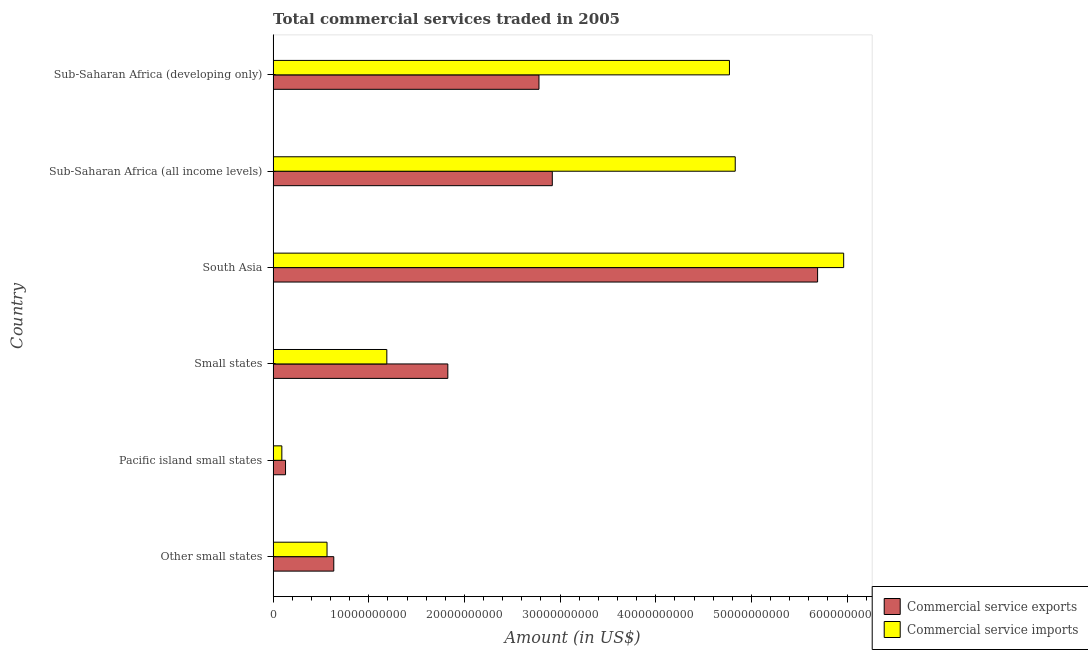Are the number of bars per tick equal to the number of legend labels?
Give a very brief answer. Yes. Are the number of bars on each tick of the Y-axis equal?
Offer a very short reply. Yes. How many bars are there on the 2nd tick from the bottom?
Offer a terse response. 2. What is the label of the 5th group of bars from the top?
Offer a very short reply. Pacific island small states. In how many cases, is the number of bars for a given country not equal to the number of legend labels?
Your answer should be compact. 0. What is the amount of commercial service exports in South Asia?
Offer a very short reply. 5.69e+1. Across all countries, what is the maximum amount of commercial service imports?
Give a very brief answer. 5.96e+1. Across all countries, what is the minimum amount of commercial service imports?
Provide a succinct answer. 9.12e+08. In which country was the amount of commercial service exports maximum?
Offer a very short reply. South Asia. In which country was the amount of commercial service imports minimum?
Your answer should be very brief. Pacific island small states. What is the total amount of commercial service imports in the graph?
Your answer should be compact. 1.74e+11. What is the difference between the amount of commercial service imports in Small states and that in South Asia?
Provide a short and direct response. -4.78e+1. What is the difference between the amount of commercial service exports in Small states and the amount of commercial service imports in Other small states?
Provide a succinct answer. 1.26e+1. What is the average amount of commercial service exports per country?
Your response must be concise. 2.33e+1. What is the difference between the amount of commercial service exports and amount of commercial service imports in Small states?
Make the answer very short. 6.38e+09. What is the ratio of the amount of commercial service exports in Pacific island small states to that in South Asia?
Provide a succinct answer. 0.02. Is the difference between the amount of commercial service imports in Pacific island small states and South Asia greater than the difference between the amount of commercial service exports in Pacific island small states and South Asia?
Your response must be concise. No. What is the difference between the highest and the second highest amount of commercial service imports?
Offer a terse response. 1.13e+1. What is the difference between the highest and the lowest amount of commercial service exports?
Make the answer very short. 5.56e+1. What does the 1st bar from the top in Other small states represents?
Provide a short and direct response. Commercial service imports. What does the 2nd bar from the bottom in Pacific island small states represents?
Offer a terse response. Commercial service imports. Are the values on the major ticks of X-axis written in scientific E-notation?
Offer a terse response. No. Does the graph contain any zero values?
Your answer should be compact. No. Does the graph contain grids?
Offer a very short reply. No. How are the legend labels stacked?
Offer a terse response. Vertical. What is the title of the graph?
Offer a very short reply. Total commercial services traded in 2005. Does "Highest 10% of population" appear as one of the legend labels in the graph?
Your answer should be very brief. No. What is the Amount (in US$) in Commercial service exports in Other small states?
Provide a short and direct response. 6.34e+09. What is the Amount (in US$) in Commercial service imports in Other small states?
Offer a terse response. 5.63e+09. What is the Amount (in US$) in Commercial service exports in Pacific island small states?
Offer a terse response. 1.30e+09. What is the Amount (in US$) in Commercial service imports in Pacific island small states?
Your answer should be compact. 9.12e+08. What is the Amount (in US$) of Commercial service exports in Small states?
Provide a short and direct response. 1.83e+1. What is the Amount (in US$) of Commercial service imports in Small states?
Offer a very short reply. 1.19e+1. What is the Amount (in US$) of Commercial service exports in South Asia?
Ensure brevity in your answer.  5.69e+1. What is the Amount (in US$) in Commercial service imports in South Asia?
Your answer should be very brief. 5.96e+1. What is the Amount (in US$) in Commercial service exports in Sub-Saharan Africa (all income levels)?
Ensure brevity in your answer.  2.92e+1. What is the Amount (in US$) in Commercial service imports in Sub-Saharan Africa (all income levels)?
Make the answer very short. 4.83e+1. What is the Amount (in US$) in Commercial service exports in Sub-Saharan Africa (developing only)?
Your answer should be very brief. 2.78e+1. What is the Amount (in US$) in Commercial service imports in Sub-Saharan Africa (developing only)?
Ensure brevity in your answer.  4.77e+1. Across all countries, what is the maximum Amount (in US$) in Commercial service exports?
Offer a very short reply. 5.69e+1. Across all countries, what is the maximum Amount (in US$) of Commercial service imports?
Provide a succinct answer. 5.96e+1. Across all countries, what is the minimum Amount (in US$) in Commercial service exports?
Your answer should be very brief. 1.30e+09. Across all countries, what is the minimum Amount (in US$) in Commercial service imports?
Keep it short and to the point. 9.12e+08. What is the total Amount (in US$) of Commercial service exports in the graph?
Keep it short and to the point. 1.40e+11. What is the total Amount (in US$) of Commercial service imports in the graph?
Your answer should be very brief. 1.74e+11. What is the difference between the Amount (in US$) in Commercial service exports in Other small states and that in Pacific island small states?
Give a very brief answer. 5.04e+09. What is the difference between the Amount (in US$) in Commercial service imports in Other small states and that in Pacific island small states?
Keep it short and to the point. 4.72e+09. What is the difference between the Amount (in US$) of Commercial service exports in Other small states and that in Small states?
Give a very brief answer. -1.19e+1. What is the difference between the Amount (in US$) in Commercial service imports in Other small states and that in Small states?
Your answer should be compact. -6.25e+09. What is the difference between the Amount (in US$) in Commercial service exports in Other small states and that in South Asia?
Offer a very short reply. -5.06e+1. What is the difference between the Amount (in US$) in Commercial service imports in Other small states and that in South Asia?
Make the answer very short. -5.40e+1. What is the difference between the Amount (in US$) of Commercial service exports in Other small states and that in Sub-Saharan Africa (all income levels)?
Your answer should be very brief. -2.28e+1. What is the difference between the Amount (in US$) of Commercial service imports in Other small states and that in Sub-Saharan Africa (all income levels)?
Make the answer very short. -4.27e+1. What is the difference between the Amount (in US$) of Commercial service exports in Other small states and that in Sub-Saharan Africa (developing only)?
Offer a terse response. -2.14e+1. What is the difference between the Amount (in US$) in Commercial service imports in Other small states and that in Sub-Saharan Africa (developing only)?
Keep it short and to the point. -4.21e+1. What is the difference between the Amount (in US$) in Commercial service exports in Pacific island small states and that in Small states?
Your answer should be compact. -1.70e+1. What is the difference between the Amount (in US$) of Commercial service imports in Pacific island small states and that in Small states?
Offer a terse response. -1.10e+1. What is the difference between the Amount (in US$) of Commercial service exports in Pacific island small states and that in South Asia?
Give a very brief answer. -5.56e+1. What is the difference between the Amount (in US$) of Commercial service imports in Pacific island small states and that in South Asia?
Your answer should be compact. -5.87e+1. What is the difference between the Amount (in US$) in Commercial service exports in Pacific island small states and that in Sub-Saharan Africa (all income levels)?
Keep it short and to the point. -2.79e+1. What is the difference between the Amount (in US$) of Commercial service imports in Pacific island small states and that in Sub-Saharan Africa (all income levels)?
Ensure brevity in your answer.  -4.74e+1. What is the difference between the Amount (in US$) of Commercial service exports in Pacific island small states and that in Sub-Saharan Africa (developing only)?
Provide a short and direct response. -2.65e+1. What is the difference between the Amount (in US$) in Commercial service imports in Pacific island small states and that in Sub-Saharan Africa (developing only)?
Keep it short and to the point. -4.68e+1. What is the difference between the Amount (in US$) in Commercial service exports in Small states and that in South Asia?
Your response must be concise. -3.87e+1. What is the difference between the Amount (in US$) in Commercial service imports in Small states and that in South Asia?
Keep it short and to the point. -4.78e+1. What is the difference between the Amount (in US$) of Commercial service exports in Small states and that in Sub-Saharan Africa (all income levels)?
Provide a succinct answer. -1.09e+1. What is the difference between the Amount (in US$) of Commercial service imports in Small states and that in Sub-Saharan Africa (all income levels)?
Keep it short and to the point. -3.64e+1. What is the difference between the Amount (in US$) in Commercial service exports in Small states and that in Sub-Saharan Africa (developing only)?
Your answer should be compact. -9.53e+09. What is the difference between the Amount (in US$) in Commercial service imports in Small states and that in Sub-Saharan Africa (developing only)?
Your response must be concise. -3.58e+1. What is the difference between the Amount (in US$) in Commercial service exports in South Asia and that in Sub-Saharan Africa (all income levels)?
Your response must be concise. 2.77e+1. What is the difference between the Amount (in US$) in Commercial service imports in South Asia and that in Sub-Saharan Africa (all income levels)?
Offer a very short reply. 1.13e+1. What is the difference between the Amount (in US$) in Commercial service exports in South Asia and that in Sub-Saharan Africa (developing only)?
Ensure brevity in your answer.  2.91e+1. What is the difference between the Amount (in US$) of Commercial service imports in South Asia and that in Sub-Saharan Africa (developing only)?
Provide a short and direct response. 1.19e+1. What is the difference between the Amount (in US$) in Commercial service exports in Sub-Saharan Africa (all income levels) and that in Sub-Saharan Africa (developing only)?
Offer a very short reply. 1.39e+09. What is the difference between the Amount (in US$) in Commercial service imports in Sub-Saharan Africa (all income levels) and that in Sub-Saharan Africa (developing only)?
Your answer should be very brief. 6.03e+08. What is the difference between the Amount (in US$) in Commercial service exports in Other small states and the Amount (in US$) in Commercial service imports in Pacific island small states?
Offer a very short reply. 5.43e+09. What is the difference between the Amount (in US$) in Commercial service exports in Other small states and the Amount (in US$) in Commercial service imports in Small states?
Ensure brevity in your answer.  -5.54e+09. What is the difference between the Amount (in US$) of Commercial service exports in Other small states and the Amount (in US$) of Commercial service imports in South Asia?
Offer a terse response. -5.33e+1. What is the difference between the Amount (in US$) of Commercial service exports in Other small states and the Amount (in US$) of Commercial service imports in Sub-Saharan Africa (all income levels)?
Your response must be concise. -4.20e+1. What is the difference between the Amount (in US$) of Commercial service exports in Other small states and the Amount (in US$) of Commercial service imports in Sub-Saharan Africa (developing only)?
Give a very brief answer. -4.14e+1. What is the difference between the Amount (in US$) in Commercial service exports in Pacific island small states and the Amount (in US$) in Commercial service imports in Small states?
Ensure brevity in your answer.  -1.06e+1. What is the difference between the Amount (in US$) of Commercial service exports in Pacific island small states and the Amount (in US$) of Commercial service imports in South Asia?
Give a very brief answer. -5.83e+1. What is the difference between the Amount (in US$) of Commercial service exports in Pacific island small states and the Amount (in US$) of Commercial service imports in Sub-Saharan Africa (all income levels)?
Your response must be concise. -4.70e+1. What is the difference between the Amount (in US$) of Commercial service exports in Pacific island small states and the Amount (in US$) of Commercial service imports in Sub-Saharan Africa (developing only)?
Offer a terse response. -4.64e+1. What is the difference between the Amount (in US$) of Commercial service exports in Small states and the Amount (in US$) of Commercial service imports in South Asia?
Give a very brief answer. -4.14e+1. What is the difference between the Amount (in US$) of Commercial service exports in Small states and the Amount (in US$) of Commercial service imports in Sub-Saharan Africa (all income levels)?
Offer a very short reply. -3.00e+1. What is the difference between the Amount (in US$) of Commercial service exports in Small states and the Amount (in US$) of Commercial service imports in Sub-Saharan Africa (developing only)?
Provide a succinct answer. -2.94e+1. What is the difference between the Amount (in US$) in Commercial service exports in South Asia and the Amount (in US$) in Commercial service imports in Sub-Saharan Africa (all income levels)?
Your answer should be compact. 8.61e+09. What is the difference between the Amount (in US$) of Commercial service exports in South Asia and the Amount (in US$) of Commercial service imports in Sub-Saharan Africa (developing only)?
Offer a very short reply. 9.21e+09. What is the difference between the Amount (in US$) in Commercial service exports in Sub-Saharan Africa (all income levels) and the Amount (in US$) in Commercial service imports in Sub-Saharan Africa (developing only)?
Give a very brief answer. -1.85e+1. What is the average Amount (in US$) in Commercial service exports per country?
Your answer should be very brief. 2.33e+1. What is the average Amount (in US$) in Commercial service imports per country?
Give a very brief answer. 2.90e+1. What is the difference between the Amount (in US$) of Commercial service exports and Amount (in US$) of Commercial service imports in Other small states?
Provide a short and direct response. 7.07e+08. What is the difference between the Amount (in US$) in Commercial service exports and Amount (in US$) in Commercial service imports in Pacific island small states?
Provide a short and direct response. 3.85e+08. What is the difference between the Amount (in US$) of Commercial service exports and Amount (in US$) of Commercial service imports in Small states?
Your response must be concise. 6.38e+09. What is the difference between the Amount (in US$) of Commercial service exports and Amount (in US$) of Commercial service imports in South Asia?
Keep it short and to the point. -2.73e+09. What is the difference between the Amount (in US$) of Commercial service exports and Amount (in US$) of Commercial service imports in Sub-Saharan Africa (all income levels)?
Offer a very short reply. -1.91e+1. What is the difference between the Amount (in US$) in Commercial service exports and Amount (in US$) in Commercial service imports in Sub-Saharan Africa (developing only)?
Provide a succinct answer. -1.99e+1. What is the ratio of the Amount (in US$) in Commercial service exports in Other small states to that in Pacific island small states?
Provide a succinct answer. 4.89. What is the ratio of the Amount (in US$) in Commercial service imports in Other small states to that in Pacific island small states?
Your answer should be compact. 6.18. What is the ratio of the Amount (in US$) in Commercial service exports in Other small states to that in Small states?
Make the answer very short. 0.35. What is the ratio of the Amount (in US$) in Commercial service imports in Other small states to that in Small states?
Keep it short and to the point. 0.47. What is the ratio of the Amount (in US$) of Commercial service exports in Other small states to that in South Asia?
Keep it short and to the point. 0.11. What is the ratio of the Amount (in US$) of Commercial service imports in Other small states to that in South Asia?
Make the answer very short. 0.09. What is the ratio of the Amount (in US$) of Commercial service exports in Other small states to that in Sub-Saharan Africa (all income levels)?
Give a very brief answer. 0.22. What is the ratio of the Amount (in US$) of Commercial service imports in Other small states to that in Sub-Saharan Africa (all income levels)?
Provide a succinct answer. 0.12. What is the ratio of the Amount (in US$) in Commercial service exports in Other small states to that in Sub-Saharan Africa (developing only)?
Provide a short and direct response. 0.23. What is the ratio of the Amount (in US$) of Commercial service imports in Other small states to that in Sub-Saharan Africa (developing only)?
Keep it short and to the point. 0.12. What is the ratio of the Amount (in US$) of Commercial service exports in Pacific island small states to that in Small states?
Give a very brief answer. 0.07. What is the ratio of the Amount (in US$) in Commercial service imports in Pacific island small states to that in Small states?
Make the answer very short. 0.08. What is the ratio of the Amount (in US$) in Commercial service exports in Pacific island small states to that in South Asia?
Provide a short and direct response. 0.02. What is the ratio of the Amount (in US$) of Commercial service imports in Pacific island small states to that in South Asia?
Make the answer very short. 0.02. What is the ratio of the Amount (in US$) of Commercial service exports in Pacific island small states to that in Sub-Saharan Africa (all income levels)?
Your response must be concise. 0.04. What is the ratio of the Amount (in US$) in Commercial service imports in Pacific island small states to that in Sub-Saharan Africa (all income levels)?
Offer a terse response. 0.02. What is the ratio of the Amount (in US$) of Commercial service exports in Pacific island small states to that in Sub-Saharan Africa (developing only)?
Provide a succinct answer. 0.05. What is the ratio of the Amount (in US$) of Commercial service imports in Pacific island small states to that in Sub-Saharan Africa (developing only)?
Offer a very short reply. 0.02. What is the ratio of the Amount (in US$) of Commercial service exports in Small states to that in South Asia?
Offer a terse response. 0.32. What is the ratio of the Amount (in US$) of Commercial service imports in Small states to that in South Asia?
Provide a succinct answer. 0.2. What is the ratio of the Amount (in US$) of Commercial service exports in Small states to that in Sub-Saharan Africa (all income levels)?
Keep it short and to the point. 0.63. What is the ratio of the Amount (in US$) of Commercial service imports in Small states to that in Sub-Saharan Africa (all income levels)?
Offer a very short reply. 0.25. What is the ratio of the Amount (in US$) in Commercial service exports in Small states to that in Sub-Saharan Africa (developing only)?
Make the answer very short. 0.66. What is the ratio of the Amount (in US$) in Commercial service imports in Small states to that in Sub-Saharan Africa (developing only)?
Provide a short and direct response. 0.25. What is the ratio of the Amount (in US$) in Commercial service exports in South Asia to that in Sub-Saharan Africa (all income levels)?
Offer a very short reply. 1.95. What is the ratio of the Amount (in US$) in Commercial service imports in South Asia to that in Sub-Saharan Africa (all income levels)?
Your answer should be compact. 1.23. What is the ratio of the Amount (in US$) in Commercial service exports in South Asia to that in Sub-Saharan Africa (developing only)?
Your response must be concise. 2.05. What is the ratio of the Amount (in US$) of Commercial service imports in South Asia to that in Sub-Saharan Africa (developing only)?
Offer a very short reply. 1.25. What is the ratio of the Amount (in US$) of Commercial service exports in Sub-Saharan Africa (all income levels) to that in Sub-Saharan Africa (developing only)?
Your answer should be compact. 1.05. What is the ratio of the Amount (in US$) of Commercial service imports in Sub-Saharan Africa (all income levels) to that in Sub-Saharan Africa (developing only)?
Provide a succinct answer. 1.01. What is the difference between the highest and the second highest Amount (in US$) of Commercial service exports?
Your answer should be very brief. 2.77e+1. What is the difference between the highest and the second highest Amount (in US$) of Commercial service imports?
Provide a succinct answer. 1.13e+1. What is the difference between the highest and the lowest Amount (in US$) in Commercial service exports?
Provide a short and direct response. 5.56e+1. What is the difference between the highest and the lowest Amount (in US$) of Commercial service imports?
Your answer should be compact. 5.87e+1. 